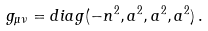Convert formula to latex. <formula><loc_0><loc_0><loc_500><loc_500>g _ { \mu \nu } = d i a g ( - n ^ { 2 } , a ^ { 2 } , a ^ { 2 } , a ^ { 2 } ) \, .</formula> 